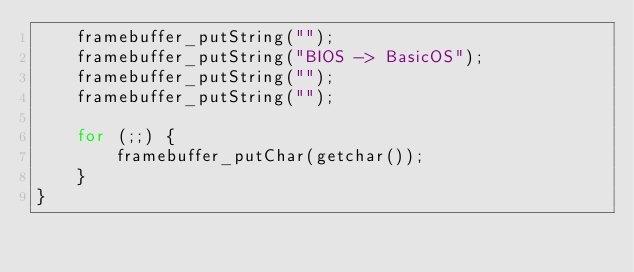Convert code to text. <code><loc_0><loc_0><loc_500><loc_500><_C_>    framebuffer_putString("");
    framebuffer_putString("BIOS -> BasicOS");
    framebuffer_putString("");
    framebuffer_putString("");

    for (;;) {
        framebuffer_putChar(getchar());
    }
}
</code> 